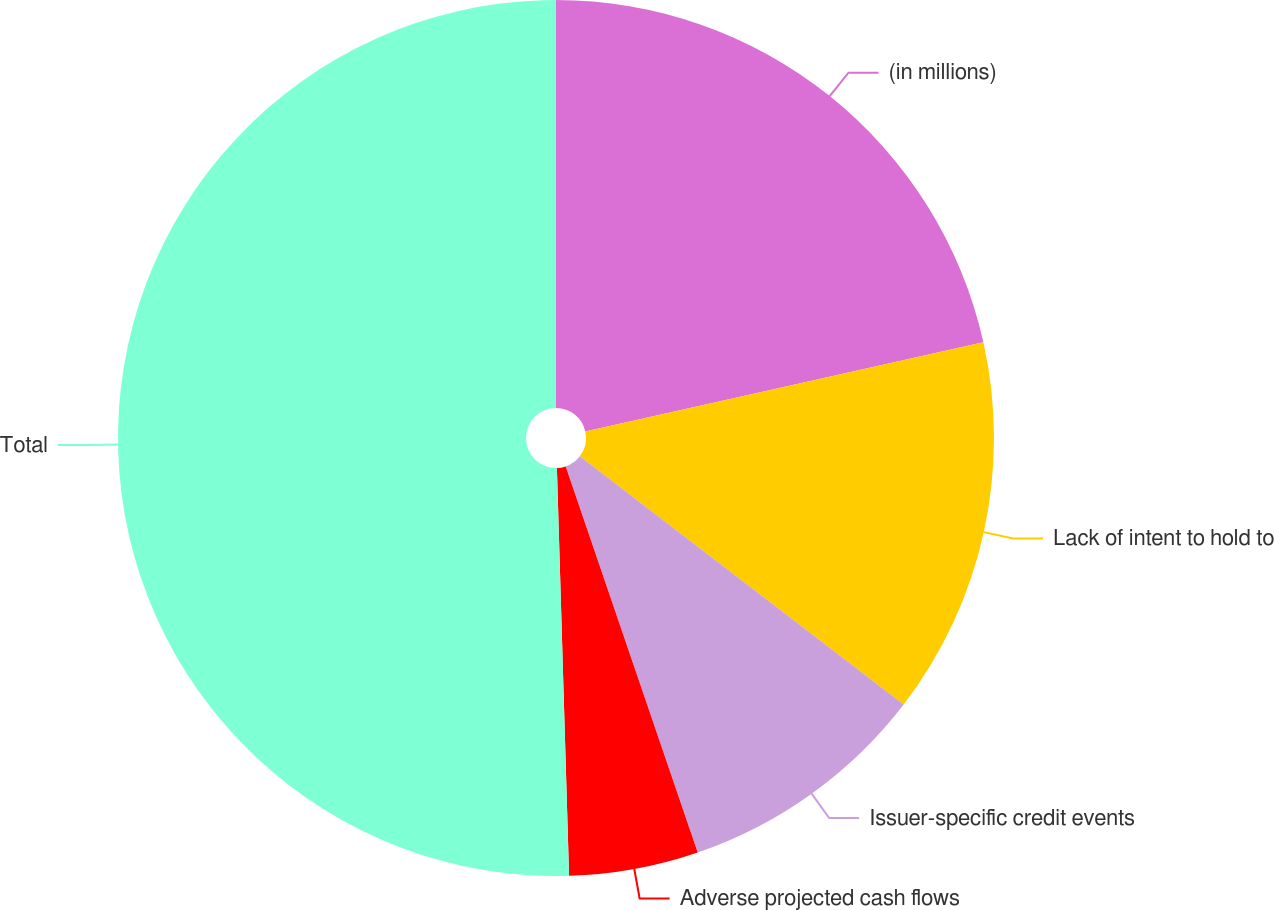<chart> <loc_0><loc_0><loc_500><loc_500><pie_chart><fcel>(in millions)<fcel>Lack of intent to hold to<fcel>Issuer-specific credit events<fcel>Adverse projected cash flows<fcel>Total<nl><fcel>21.49%<fcel>13.92%<fcel>9.35%<fcel>4.77%<fcel>50.48%<nl></chart> 